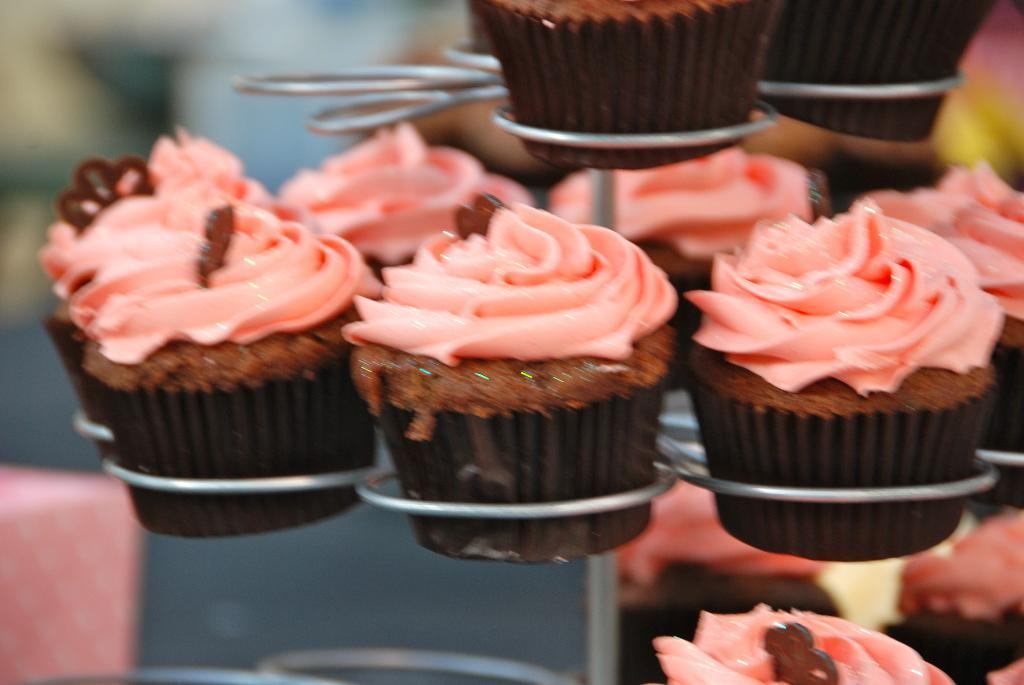What type of dessert can be seen in the image? There are cupcakes in the image. How are the cupcakes arranged or displayed? The cupcakes are on a cupcake holder. Can you describe the background of the image? The background of the image is blurry. What type of fruit is being played with in the image? There is no fruit or playing activity present in the image. 